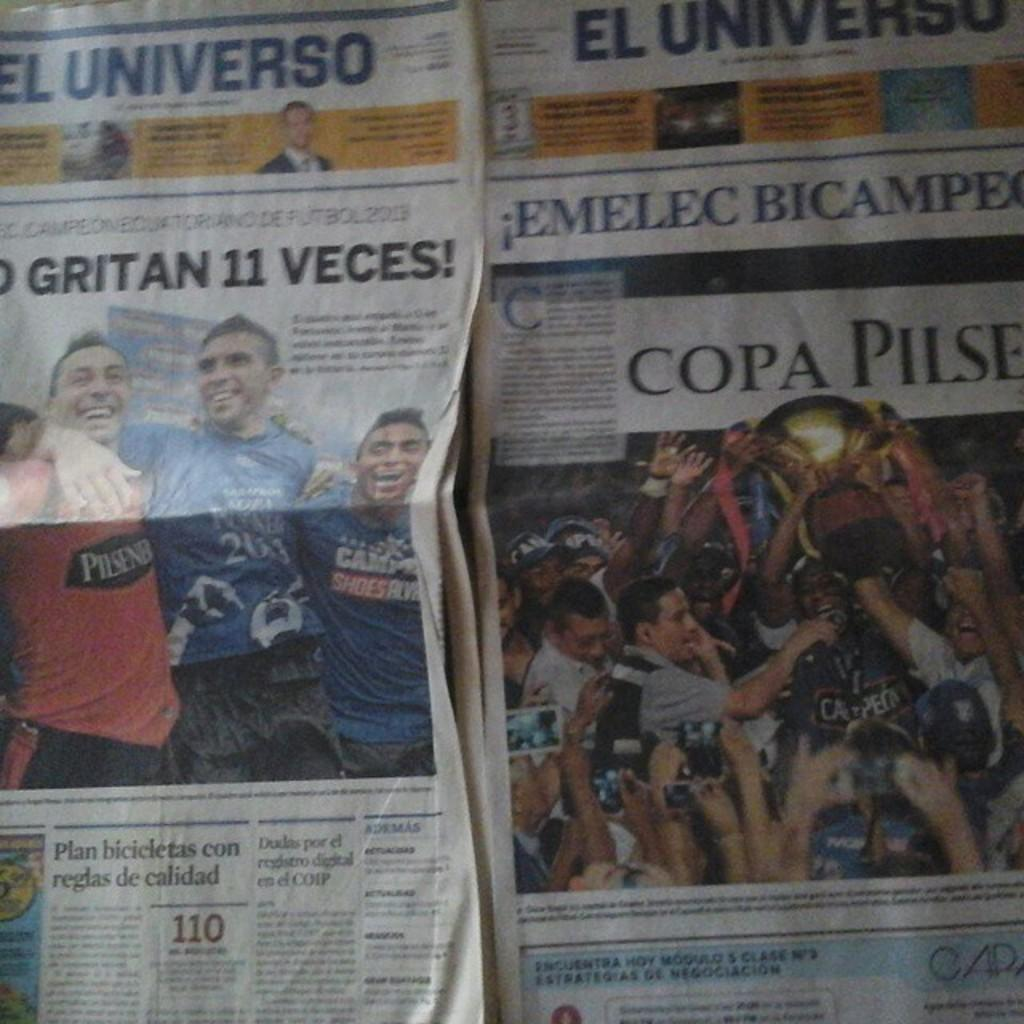What is the main object in the image? There is a newspaper in the image. What can be seen on the newspaper? Some information is visible on the newspaper. How many cars are parked in front of the religious building mentioned in the newspaper article? There is no information about cars or religious buildings in the image, as it only features a newspaper with some visible information. 